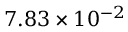Convert formula to latex. <formula><loc_0><loc_0><loc_500><loc_500>7 . 8 3 \times 1 0 ^ { - 2 }</formula> 